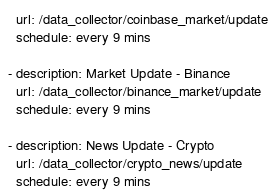Convert code to text. <code><loc_0><loc_0><loc_500><loc_500><_YAML_>  url: /data_collector/coinbase_market/update
  schedule: every 9 mins

- description: Market Update - Binance
  url: /data_collector/binance_market/update
  schedule: every 9 mins

- description: News Update - Crypto
  url: /data_collector/crypto_news/update
  schedule: every 9 mins</code> 